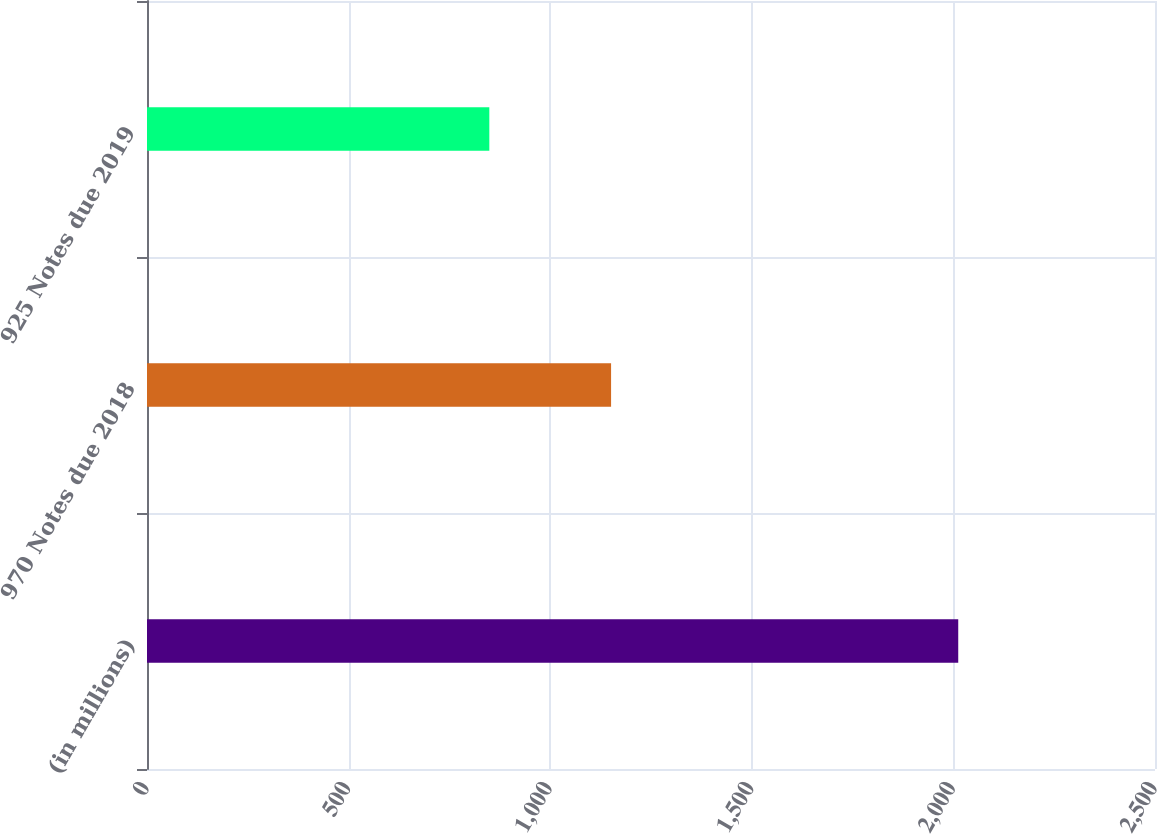<chart> <loc_0><loc_0><loc_500><loc_500><bar_chart><fcel>(in millions)<fcel>970 Notes due 2018<fcel>925 Notes due 2019<nl><fcel>2012<fcel>1151<fcel>849<nl></chart> 